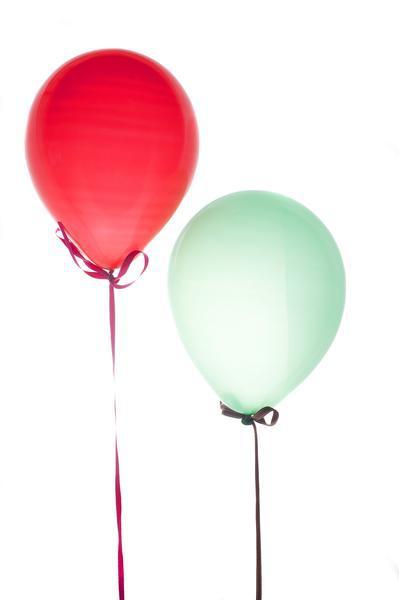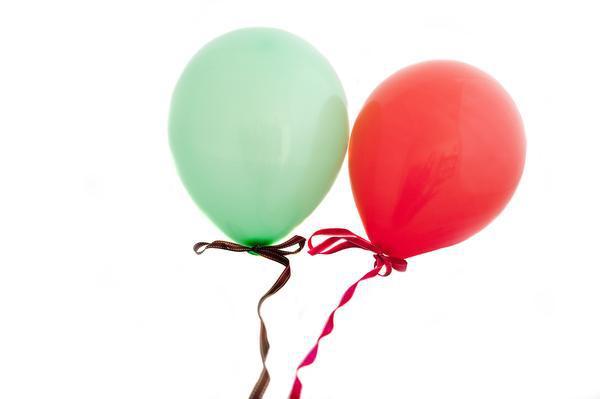The first image is the image on the left, the second image is the image on the right. Analyze the images presented: Is the assertion "There are two red balloons out of the four shown." valid? Answer yes or no. Yes. 